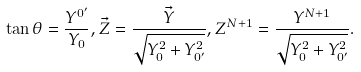Convert formula to latex. <formula><loc_0><loc_0><loc_500><loc_500>\tan \theta = \frac { Y ^ { 0 ^ { \prime } } } { Y _ { 0 } } , \vec { Z } = \frac { \vec { Y } } { \sqrt { Y _ { 0 } ^ { 2 } + Y _ { 0 ^ { \prime } } ^ { 2 } } } , Z ^ { N + 1 } = \frac { Y ^ { N + 1 } } { \sqrt { Y _ { 0 } ^ { 2 } + Y _ { 0 ^ { \prime } } ^ { 2 } } } .</formula> 